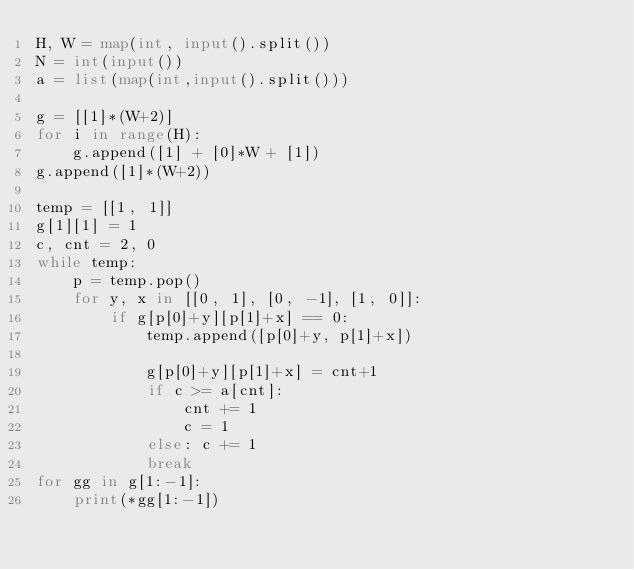<code> <loc_0><loc_0><loc_500><loc_500><_Python_>H, W = map(int, input().split())
N = int(input())
a = list(map(int,input().split()))

g = [[1]*(W+2)]
for i in range(H):
    g.append([1] + [0]*W + [1])
g.append([1]*(W+2))

temp = [[1, 1]]
g[1][1] = 1
c, cnt = 2, 0
while temp:
    p = temp.pop()
    for y, x in [[0, 1], [0, -1], [1, 0]]:
        if g[p[0]+y][p[1]+x] == 0:
            temp.append([p[0]+y, p[1]+x])
            
            g[p[0]+y][p[1]+x] = cnt+1
            if c >= a[cnt]:
                cnt += 1
                c = 1
            else: c += 1
            break
for gg in g[1:-1]:
    print(*gg[1:-1])</code> 